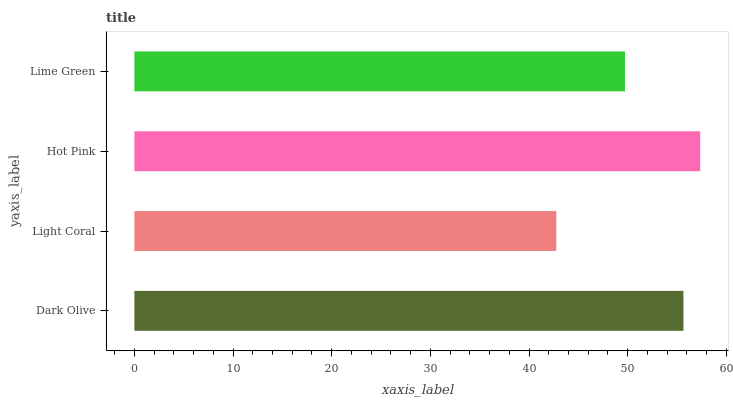Is Light Coral the minimum?
Answer yes or no. Yes. Is Hot Pink the maximum?
Answer yes or no. Yes. Is Hot Pink the minimum?
Answer yes or no. No. Is Light Coral the maximum?
Answer yes or no. No. Is Hot Pink greater than Light Coral?
Answer yes or no. Yes. Is Light Coral less than Hot Pink?
Answer yes or no. Yes. Is Light Coral greater than Hot Pink?
Answer yes or no. No. Is Hot Pink less than Light Coral?
Answer yes or no. No. Is Dark Olive the high median?
Answer yes or no. Yes. Is Lime Green the low median?
Answer yes or no. Yes. Is Lime Green the high median?
Answer yes or no. No. Is Dark Olive the low median?
Answer yes or no. No. 